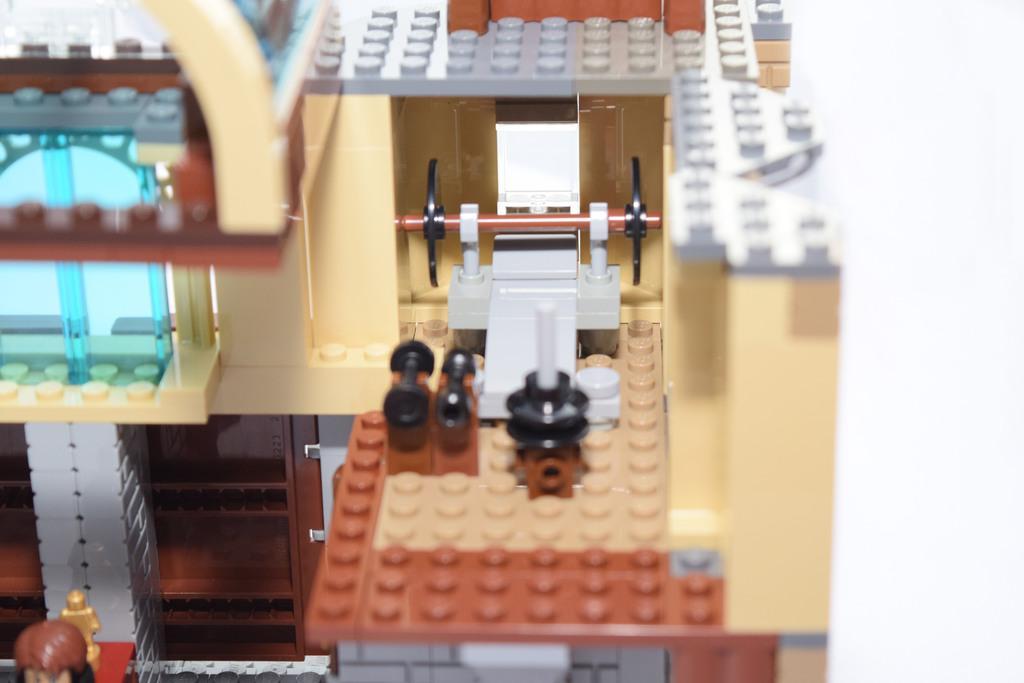Please provide a concise description of this image. In this picture I can see lego game. 